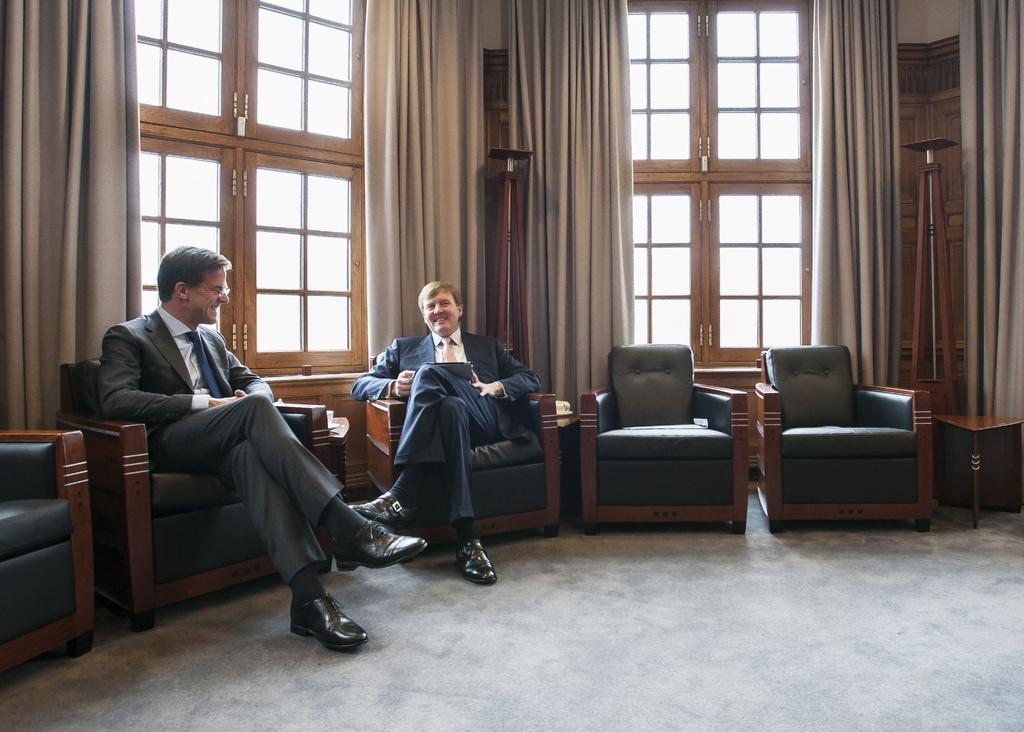How many people are present in the image? There are two people in the image. What are the two people doing in the image? The two people are sitting on a couch. What is the facial expression of the two people? The two people are smiling. What can be seen in the background of the image? There are curtains in the background of the image. What are the curtains associated with? The curtains are associated with windows. What type of stick is the daughter holding in the image? There is no daughter or stick present in the image. 